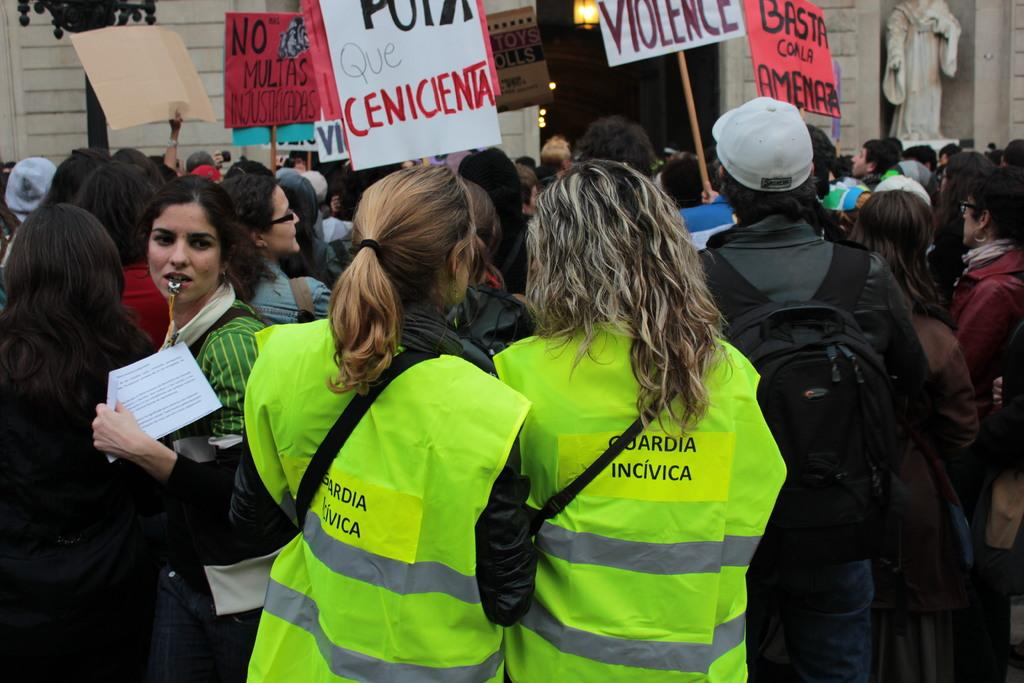What can be seen in the image? There is a group of people in the image. What else is present in the image besides the group of people? There are banners in the image. What can be seen in the background of the image? There are buildings in the background of the image. Can you describe the clothing of two women in the front of the image? Two women are wearing green color jackets in the front of the image. What type of vegetable is being used as a pest control method in the image? There is no vegetable or pest control method present in the image. 